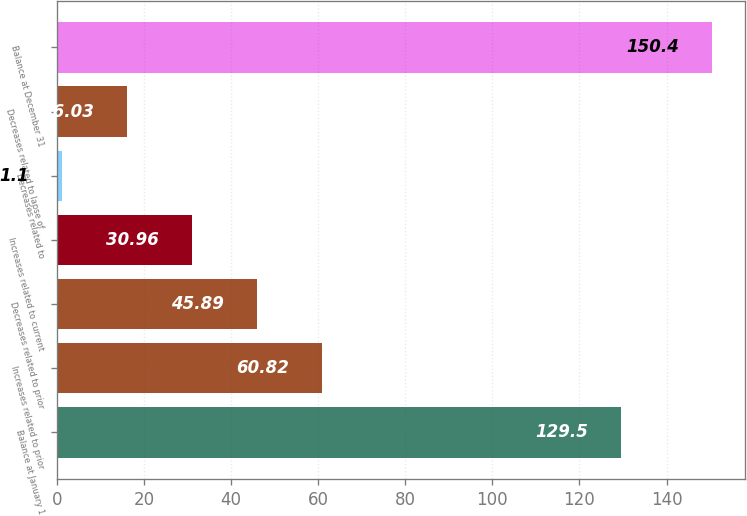<chart> <loc_0><loc_0><loc_500><loc_500><bar_chart><fcel>Balance at January 1<fcel>Increases related to prior<fcel>Decreases related to prior<fcel>Increases related to current<fcel>Decreases related to<fcel>Decreases related to lapse of<fcel>Balance at December 31<nl><fcel>129.5<fcel>60.82<fcel>45.89<fcel>30.96<fcel>1.1<fcel>16.03<fcel>150.4<nl></chart> 